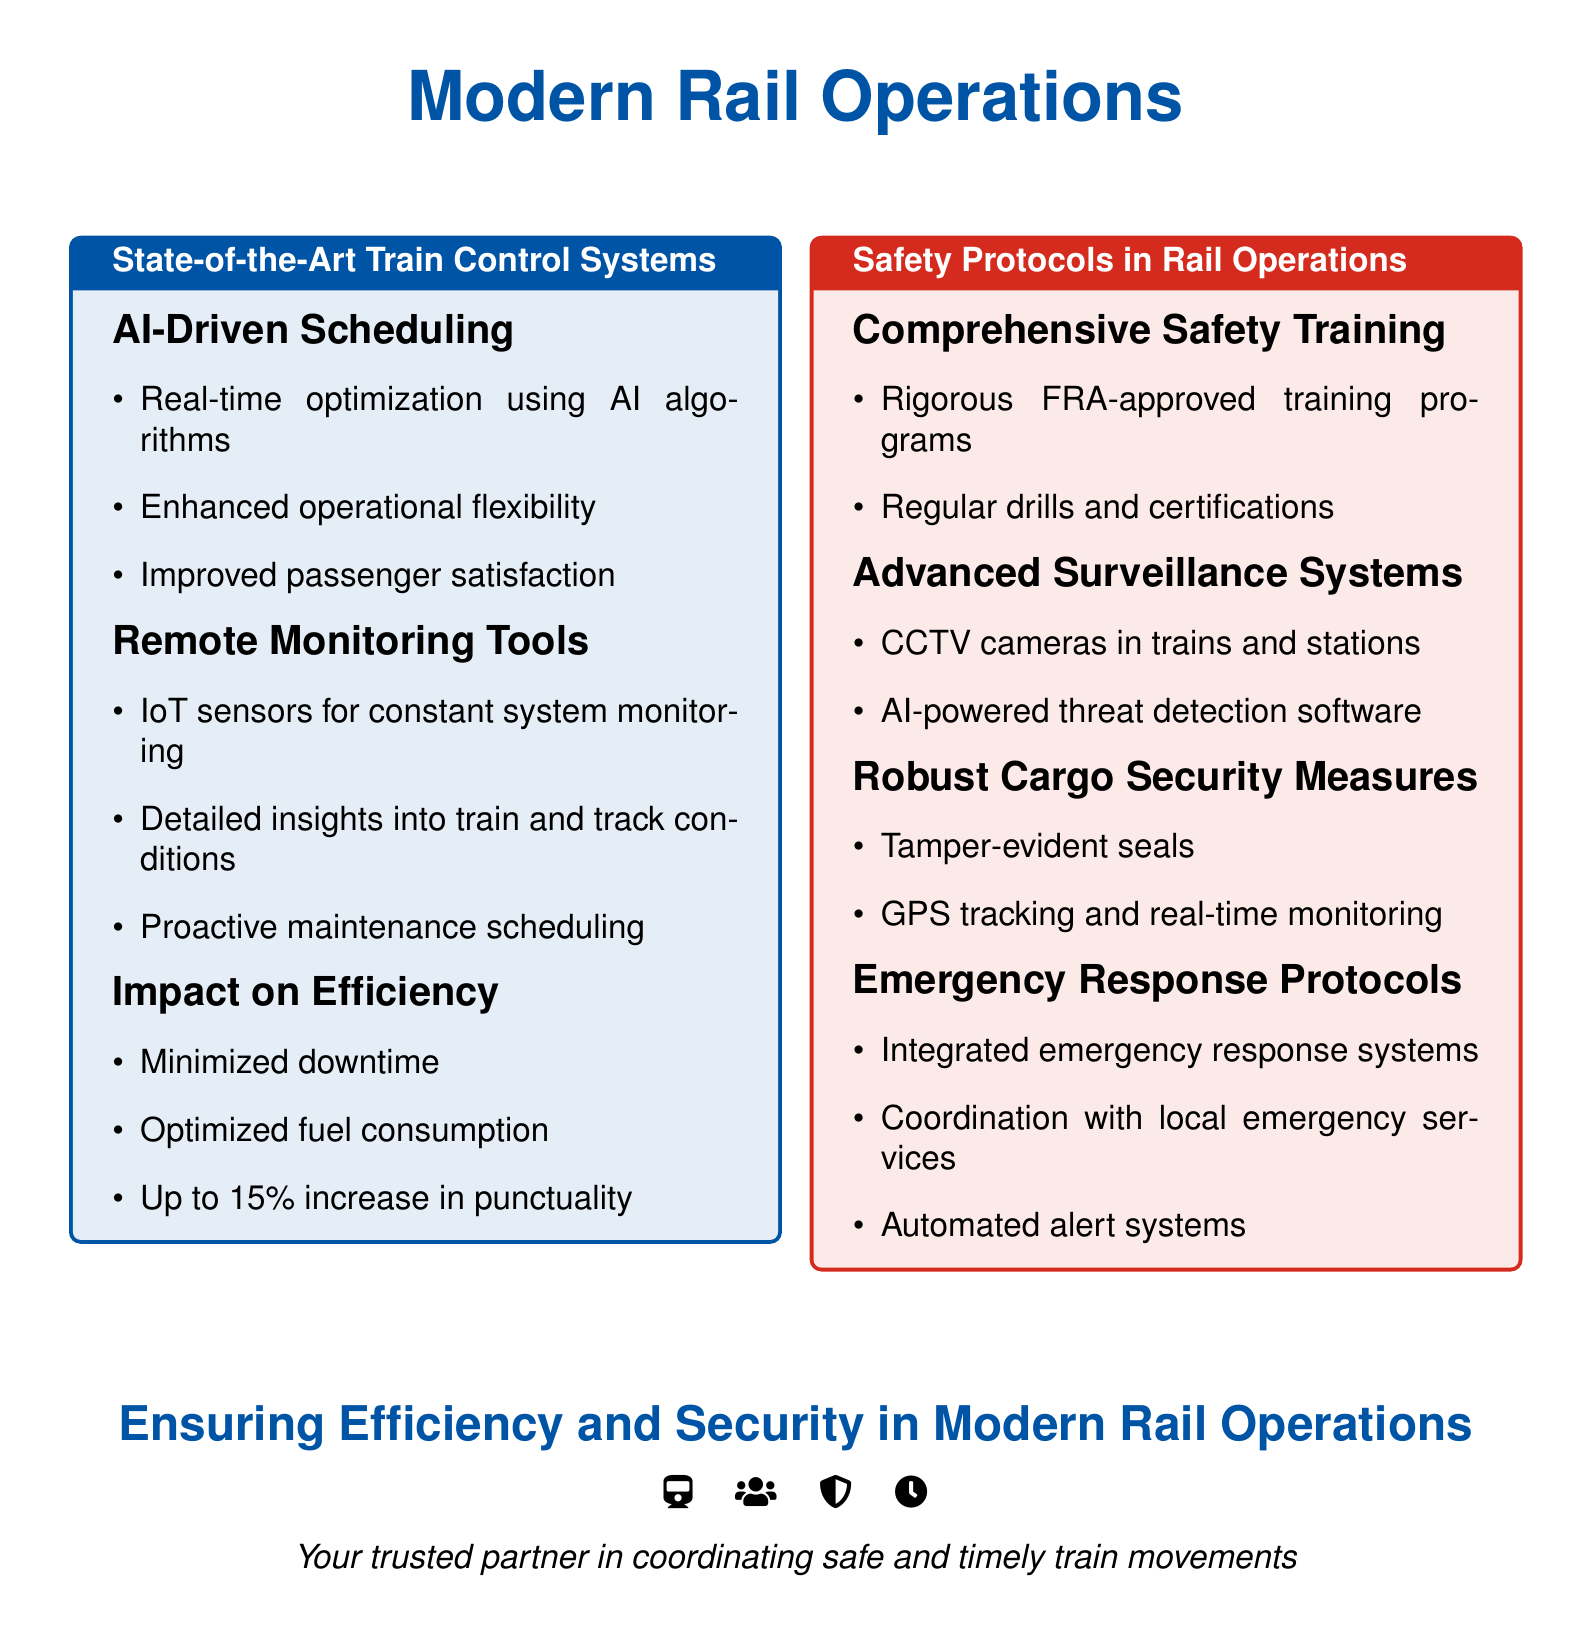What is the primary color theme of the document? The document features a color theme with shades of blue and red.
Answer: blue and red What technology is used for monitoring train and track conditions? The document mentions IoT sensors as the technology used for monitoring.
Answer: IoT sensors What percentage increase in punctuality is mentioned? The document states an increase of up to 15% in punctuality.
Answer: 15% What type of training is emphasized for safety? The document highlights comprehensive safety training as a key aspect.
Answer: comprehensive safety training What system is used for threat detection? The document refers to AI-powered threat detection software as the system used.
Answer: AI-powered threat detection software Which protocol is integrated for emergencies? The document specifies the use of integrated emergency response systems.
Answer: emergency response systems How many columns are there in the document? The document is arranged into two columns for layout.
Answer: two What is the slogan at the end of the document? The document concludes with the phrase about being a trusted partner in coordinating safe and timely train movements.
Answer: Your trusted partner in coordinating safe and timely train movements What do tamper-evident seals provide? The document states that tamper-evident seals provide security for cargo.
Answer: security for cargo 